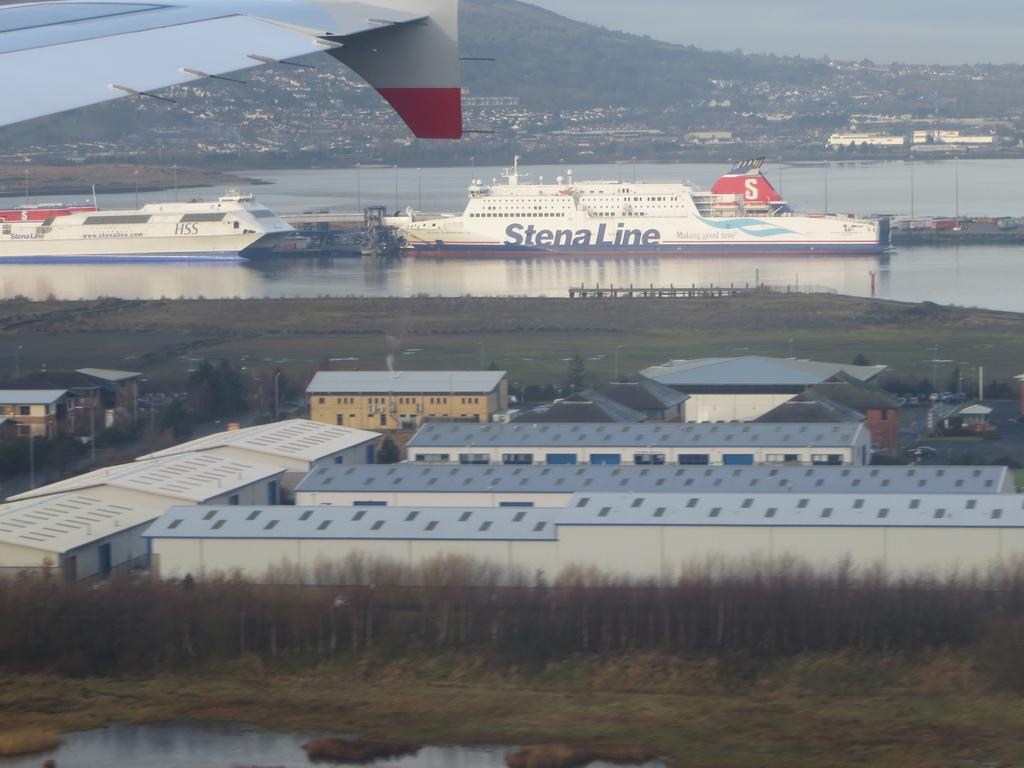<image>
Share a concise interpretation of the image provided. A Stena Line ship is sailing in the distance. 